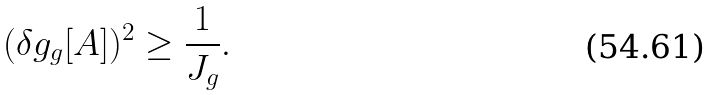<formula> <loc_0><loc_0><loc_500><loc_500>( \delta g _ { g } [ A ] ) ^ { 2 } \geq \frac { 1 } { J _ { g } } .</formula> 